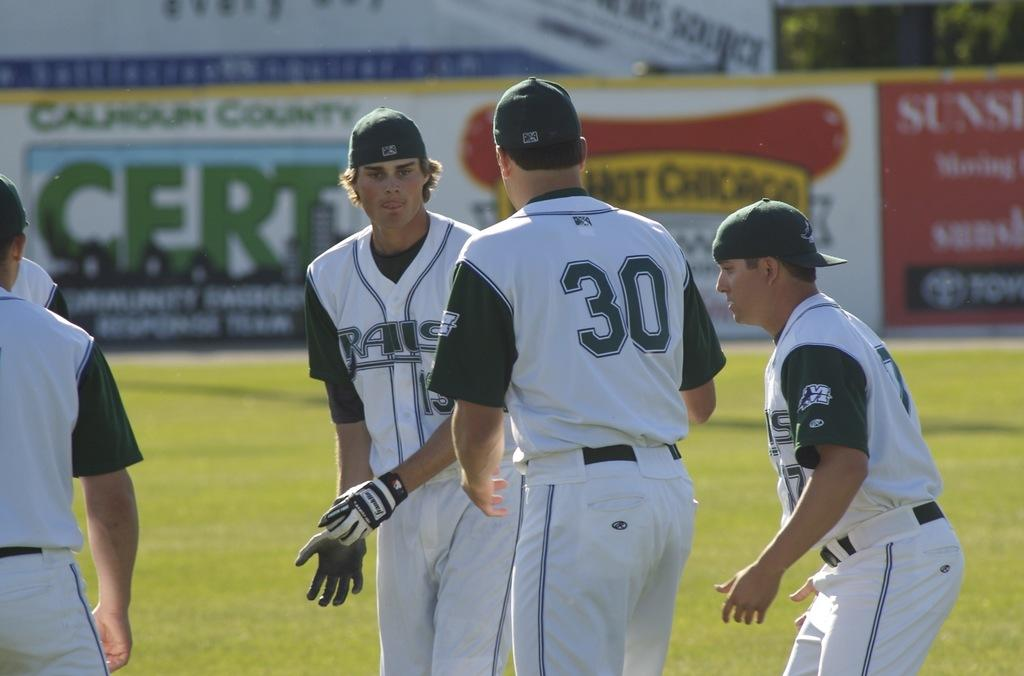<image>
Present a compact description of the photo's key features. A group of players stand together including one wear the number 30 shirt. 